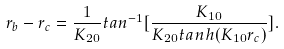Convert formula to latex. <formula><loc_0><loc_0><loc_500><loc_500>r _ { b } - r _ { c } = \frac { 1 } { K _ { 2 0 } } t a n ^ { - 1 } [ \frac { K _ { 1 0 } } { K _ { 2 0 } t a n h ( K _ { 1 0 } r _ { c } ) } ] .</formula> 